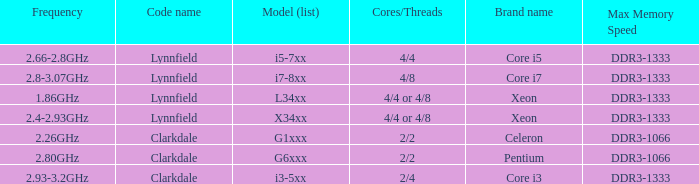What frequency does the Pentium processor use? 2.80GHz. Could you help me parse every detail presented in this table? {'header': ['Frequency', 'Code name', 'Model (list)', 'Cores/Threads', 'Brand name', 'Max Memory Speed'], 'rows': [['2.66-2.8GHz', 'Lynnfield', 'i5-7xx', '4/4', 'Core i5', 'DDR3-1333'], ['2.8-3.07GHz', 'Lynnfield', 'i7-8xx', '4/8', 'Core i7', 'DDR3-1333'], ['1.86GHz', 'Lynnfield', 'L34xx', '4/4 or 4/8', 'Xeon', 'DDR3-1333'], ['2.4-2.93GHz', 'Lynnfield', 'X34xx', '4/4 or 4/8', 'Xeon', 'DDR3-1333'], ['2.26GHz', 'Clarkdale', 'G1xxx', '2/2', 'Celeron', 'DDR3-1066'], ['2.80GHz', 'Clarkdale', 'G6xxx', '2/2', 'Pentium', 'DDR3-1066'], ['2.93-3.2GHz', 'Clarkdale', 'i3-5xx', '2/4', 'Core i3', 'DDR3-1333']]} 